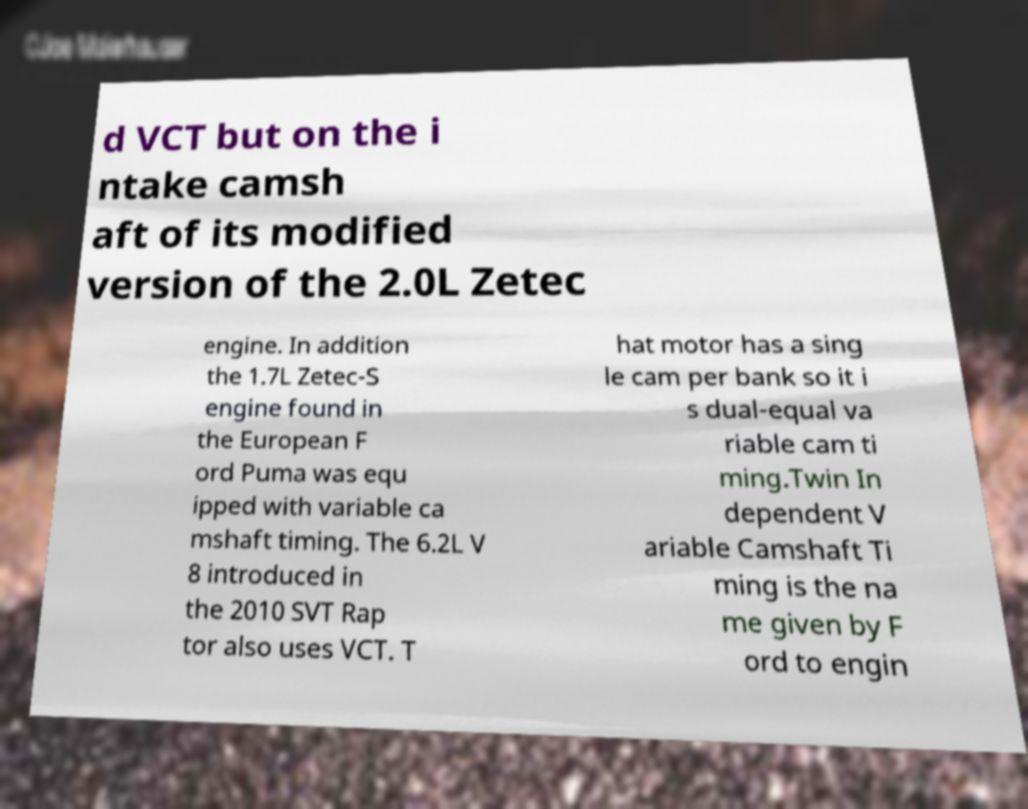Can you accurately transcribe the text from the provided image for me? d VCT but on the i ntake camsh aft of its modified version of the 2.0L Zetec engine. In addition the 1.7L Zetec-S engine found in the European F ord Puma was equ ipped with variable ca mshaft timing. The 6.2L V 8 introduced in the 2010 SVT Rap tor also uses VCT. T hat motor has a sing le cam per bank so it i s dual-equal va riable cam ti ming.Twin In dependent V ariable Camshaft Ti ming is the na me given by F ord to engin 